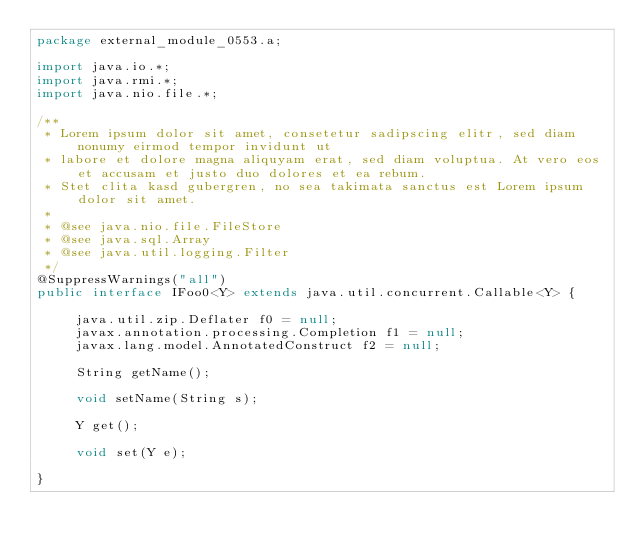Convert code to text. <code><loc_0><loc_0><loc_500><loc_500><_Java_>package external_module_0553.a;

import java.io.*;
import java.rmi.*;
import java.nio.file.*;

/**
 * Lorem ipsum dolor sit amet, consetetur sadipscing elitr, sed diam nonumy eirmod tempor invidunt ut 
 * labore et dolore magna aliquyam erat, sed diam voluptua. At vero eos et accusam et justo duo dolores et ea rebum. 
 * Stet clita kasd gubergren, no sea takimata sanctus est Lorem ipsum dolor sit amet. 
 *
 * @see java.nio.file.FileStore
 * @see java.sql.Array
 * @see java.util.logging.Filter
 */
@SuppressWarnings("all")
public interface IFoo0<Y> extends java.util.concurrent.Callable<Y> {

	 java.util.zip.Deflater f0 = null;
	 javax.annotation.processing.Completion f1 = null;
	 javax.lang.model.AnnotatedConstruct f2 = null;

	 String getName();

	 void setName(String s);

	 Y get();

	 void set(Y e);

}
</code> 